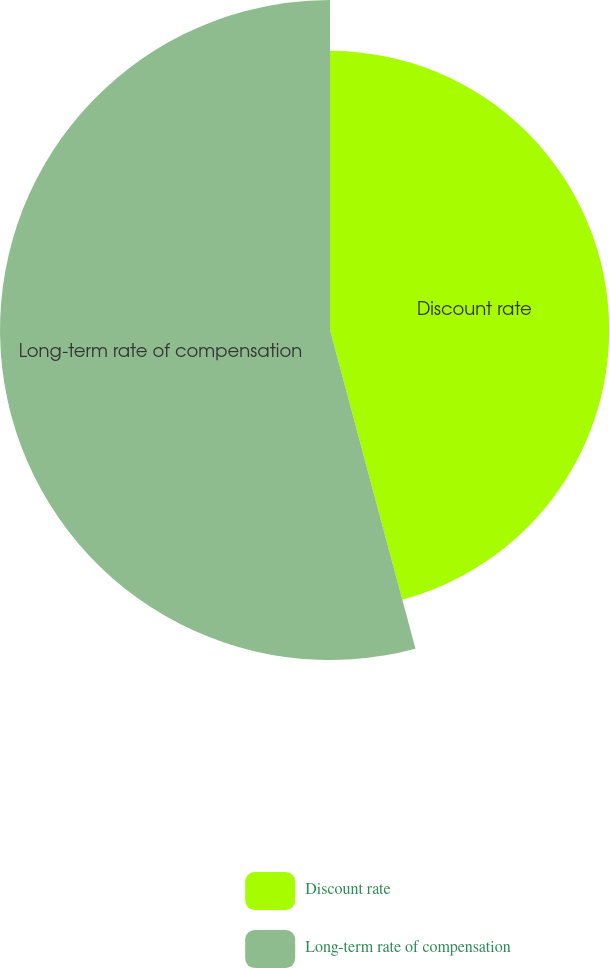Convert chart to OTSL. <chart><loc_0><loc_0><loc_500><loc_500><pie_chart><fcel>Discount rate<fcel>Long-term rate of compensation<nl><fcel>45.83%<fcel>54.17%<nl></chart> 